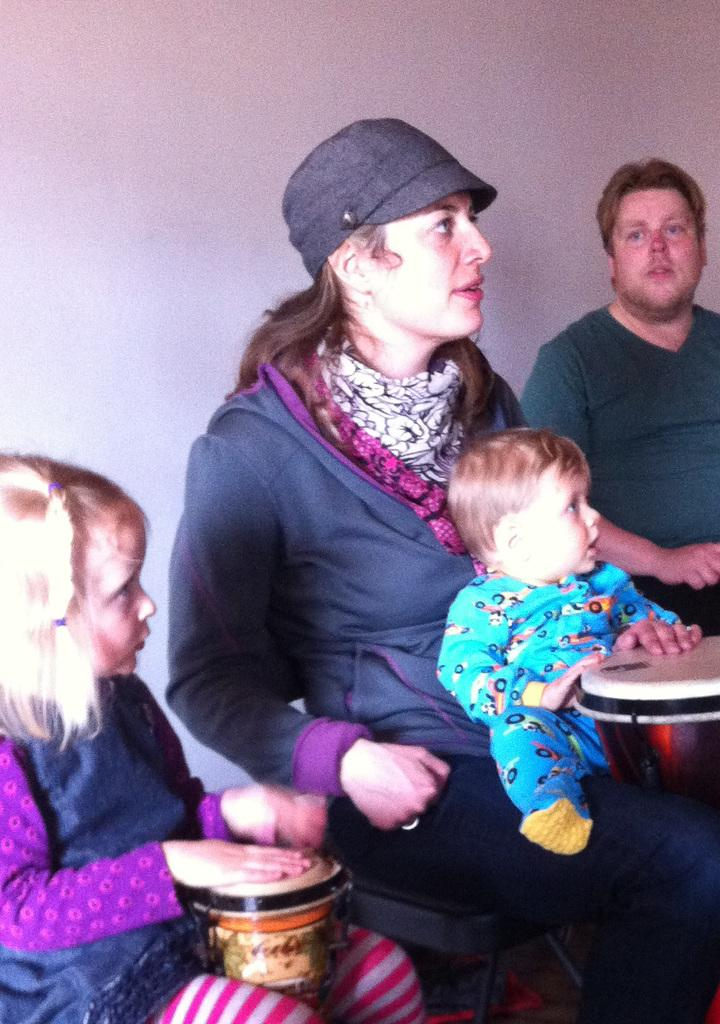How many people are present in the image? There are four people in the image: a woman, a small girl, a small boy, and a man. What is the small girl doing in the image? The small girl is sitting in the image. How is the small boy positioned in relation to the woman? The small boy is sitting on the woman's lap in the image. What is the man doing in the image? The man is standing in the image. What activity is the girl engaged in? The girl is playing a musical instrument in the image. What type of spoon is the small boy using to play with the appliance in the image? There is no spoon or appliance present in the image. What is the woman's desire in the image? The facts provided do not give any information about the woman's desires or emotions, so it cannot be determined from the image. 